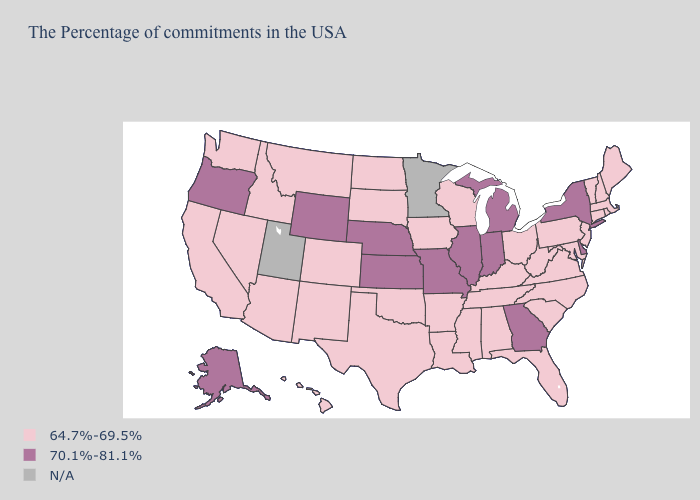Among the states that border Utah , does Idaho have the lowest value?
Be succinct. Yes. Does Georgia have the highest value in the USA?
Quick response, please. Yes. Does Wyoming have the highest value in the West?
Be succinct. Yes. Name the states that have a value in the range 70.1%-81.1%?
Concise answer only. New York, Delaware, Georgia, Michigan, Indiana, Illinois, Missouri, Kansas, Nebraska, Wyoming, Oregon, Alaska. What is the lowest value in the USA?
Give a very brief answer. 64.7%-69.5%. Which states have the lowest value in the USA?
Give a very brief answer. Maine, Massachusetts, Rhode Island, New Hampshire, Vermont, Connecticut, New Jersey, Maryland, Pennsylvania, Virginia, North Carolina, South Carolina, West Virginia, Ohio, Florida, Kentucky, Alabama, Tennessee, Wisconsin, Mississippi, Louisiana, Arkansas, Iowa, Oklahoma, Texas, South Dakota, North Dakota, Colorado, New Mexico, Montana, Arizona, Idaho, Nevada, California, Washington, Hawaii. What is the value of Washington?
Short answer required. 64.7%-69.5%. Name the states that have a value in the range 64.7%-69.5%?
Concise answer only. Maine, Massachusetts, Rhode Island, New Hampshire, Vermont, Connecticut, New Jersey, Maryland, Pennsylvania, Virginia, North Carolina, South Carolina, West Virginia, Ohio, Florida, Kentucky, Alabama, Tennessee, Wisconsin, Mississippi, Louisiana, Arkansas, Iowa, Oklahoma, Texas, South Dakota, North Dakota, Colorado, New Mexico, Montana, Arizona, Idaho, Nevada, California, Washington, Hawaii. Does Wyoming have the lowest value in the USA?
Answer briefly. No. Does New York have the lowest value in the USA?
Write a very short answer. No. What is the lowest value in states that border California?
Quick response, please. 64.7%-69.5%. Name the states that have a value in the range 64.7%-69.5%?
Be succinct. Maine, Massachusetts, Rhode Island, New Hampshire, Vermont, Connecticut, New Jersey, Maryland, Pennsylvania, Virginia, North Carolina, South Carolina, West Virginia, Ohio, Florida, Kentucky, Alabama, Tennessee, Wisconsin, Mississippi, Louisiana, Arkansas, Iowa, Oklahoma, Texas, South Dakota, North Dakota, Colorado, New Mexico, Montana, Arizona, Idaho, Nevada, California, Washington, Hawaii. 